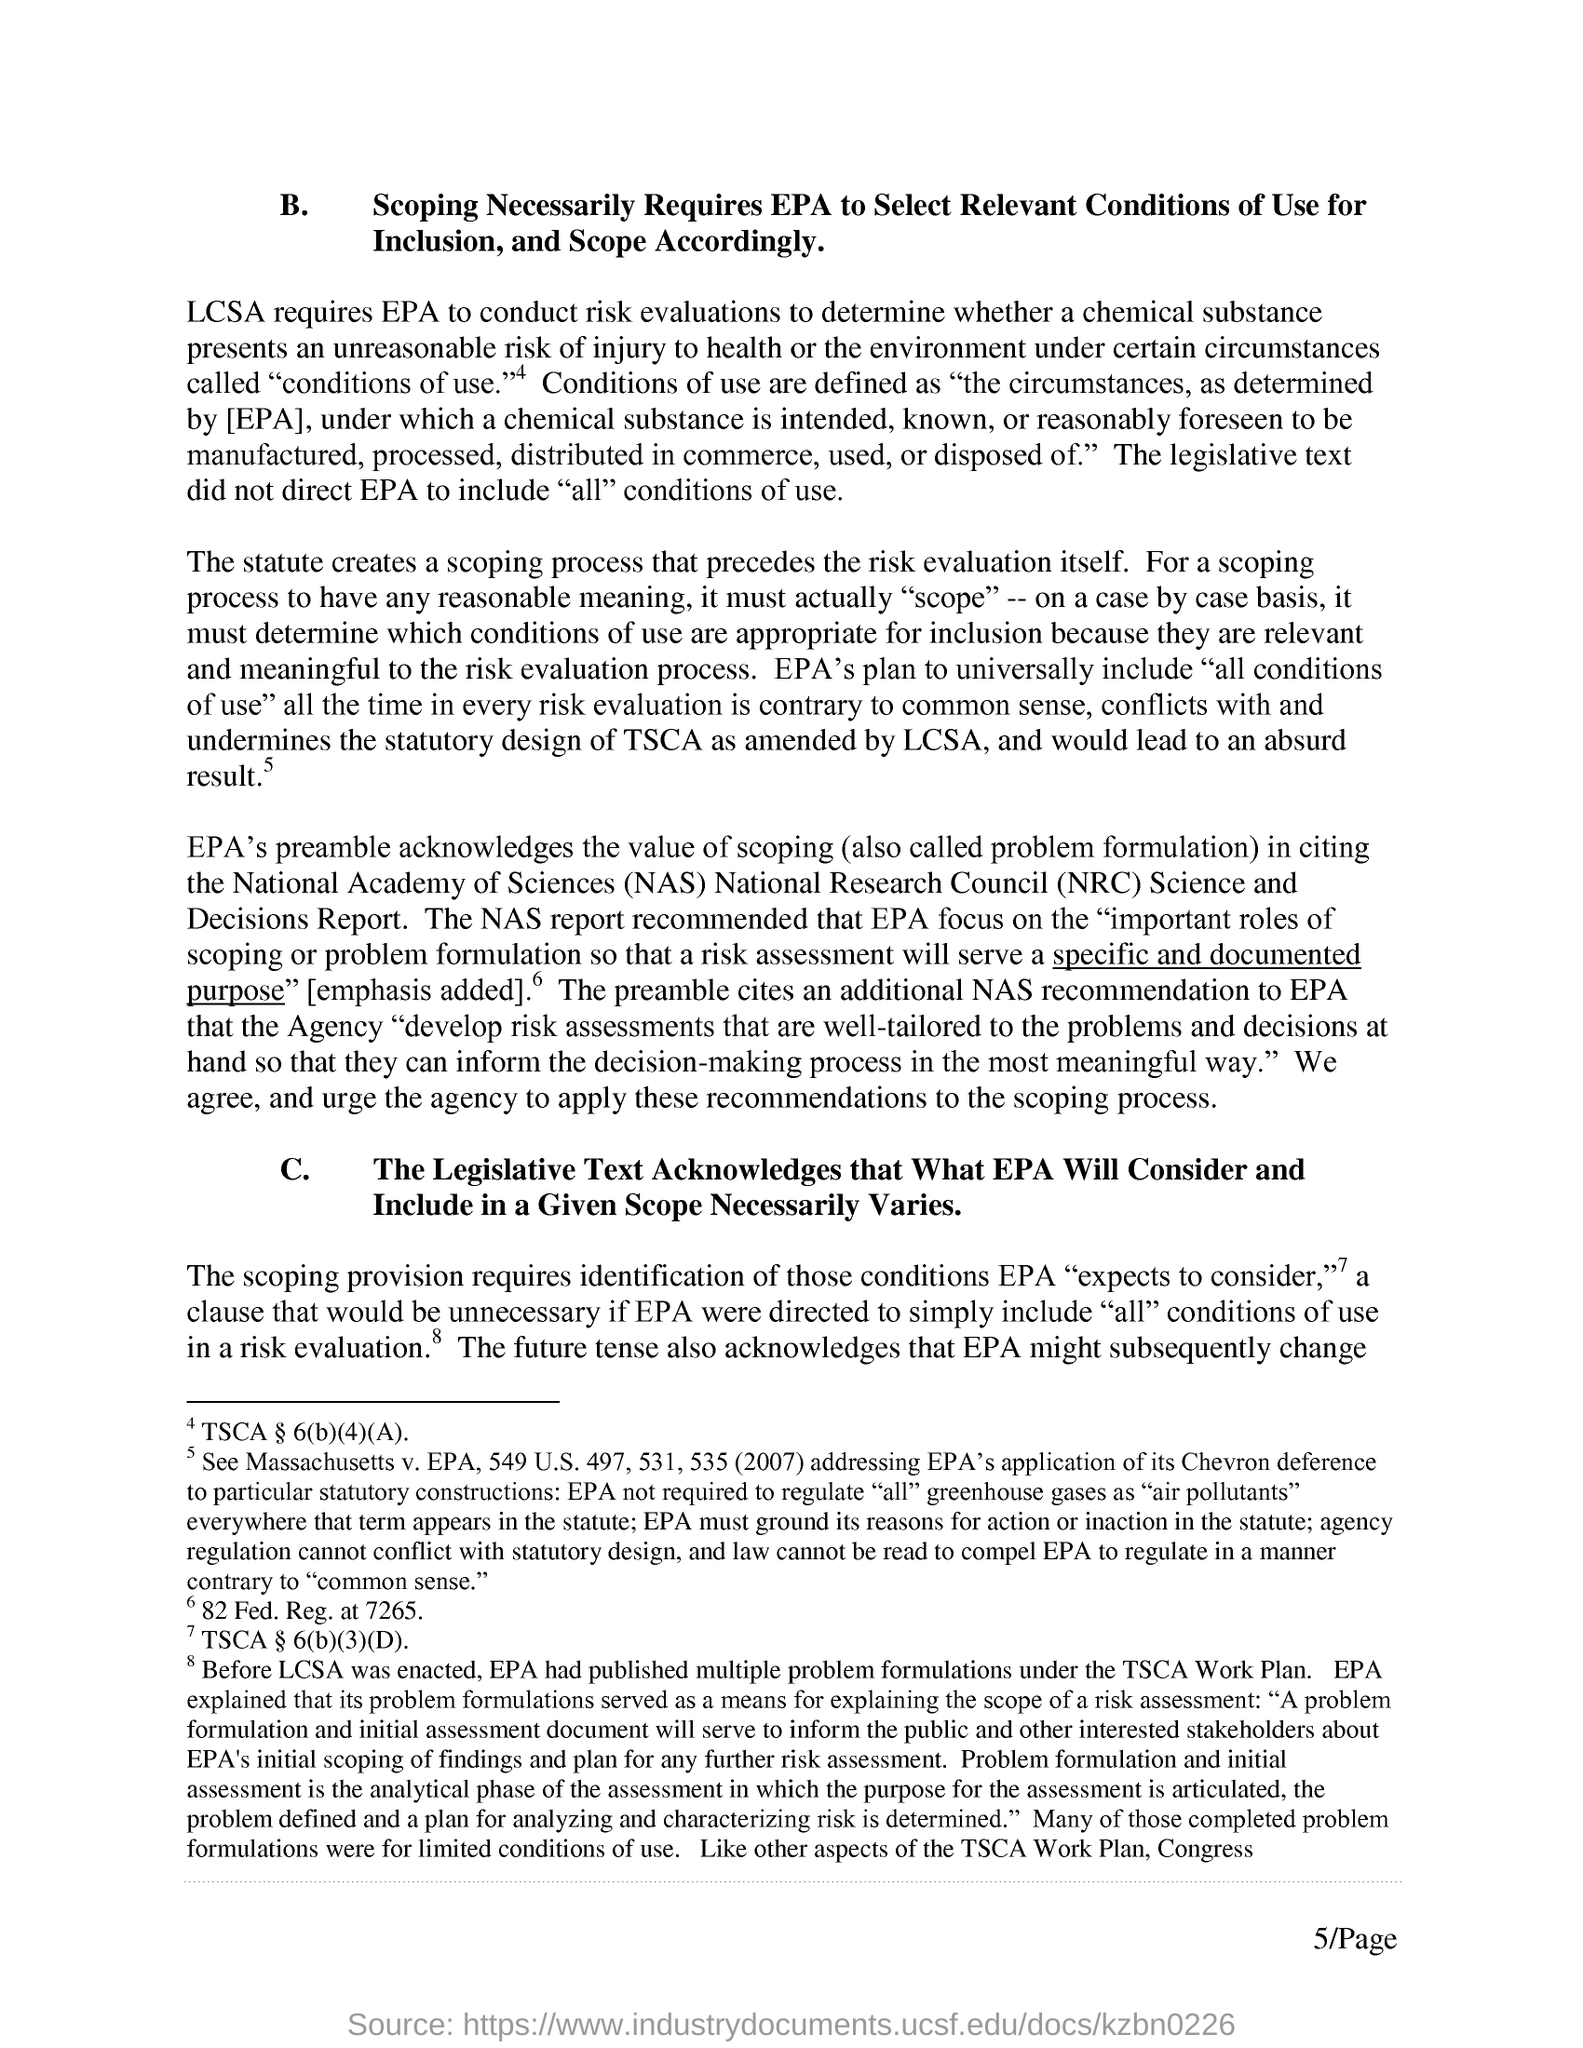Mention a couple of crucial points in this snapshot. The Leadership and Cultural SHAPE Assessment requires an evaluation of risks to be conducted by the Environmental Protection Agency (EPA). The speaker is inquiring about the page number of a document that is located at the bottom right of the page. The number is 5. Under what EPA had published multiple problem formulations? The Toxic Substances Control Act (TSCA) Work Plan. The National Academy of Sciences (NAS) report recommends that the Environmental Protection Agency (EPA) focus on the important roles of scoping and problem formulation in risk assessment to ensure that the assessment serves a specific and documented purpose. B." is the first heading given in the text, and it is followed by the sentence "Scoping necessarily requires EPA to select relevant conditions of use for inclusion and scope accordingly. 